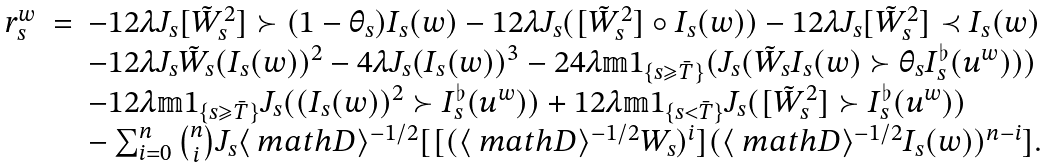<formula> <loc_0><loc_0><loc_500><loc_500>\begin{array} { l l l } r _ { s } ^ { w } & = & - 1 2 \lambda J _ { s } [ \tilde { W } _ { s } ^ { 2 } ] \succ ( 1 - \theta _ { s } ) I _ { s } ( w ) - 1 2 \lambda J _ { s } ( [ \tilde { W } _ { s } ^ { 2 } ] \circ I _ { s } ( w ) ) - 1 2 \lambda J _ { s } [ \tilde { W } _ { s } ^ { 2 } ] \prec I _ { s } ( w ) \\ & & - 1 2 \lambda J _ { s } \tilde { W } _ { s } ( I _ { s } ( w ) ) ^ { 2 } - 4 \lambda J _ { s } ( I _ { s } ( w ) ) ^ { 3 } - 2 4 \lambda \mathbb { m } { 1 } _ { \{ s \geqslant \bar { T } \} } ( J _ { s } ( \tilde { W } _ { s } I _ { s } ( w ) \succ \theta _ { s } I ^ { \flat } _ { s } ( u ^ { w } ) ) ) \\ & & - 1 2 \lambda \mathbb { m } { 1 } _ { \{ s \geqslant \bar { T } \} } J _ { s } ( ( I _ { s } ( w ) ) ^ { 2 } \succ I ^ { \flat } _ { s } ( u ^ { w } ) ) + 1 2 \lambda \mathbb { m } { 1 } _ { \{ s < \bar { T } \} } J _ { s } ( [ \tilde { W } _ { s } ^ { 2 } ] \succ I _ { s } ^ { \flat } ( u ^ { w } ) ) \\ & & - \sum _ { i = 0 } ^ { n } \binom { n } { i } J _ { s } \langle \ m a t h D \rangle ^ { - 1 / 2 } [ [ ( \langle \ m a t h D \rangle ^ { - 1 / 2 } W _ { s } ) ^ { i } ] ( \langle \ m a t h D \rangle ^ { - 1 / 2 } I _ { s } ( w ) ) ^ { n - i } ] . \end{array}</formula> 